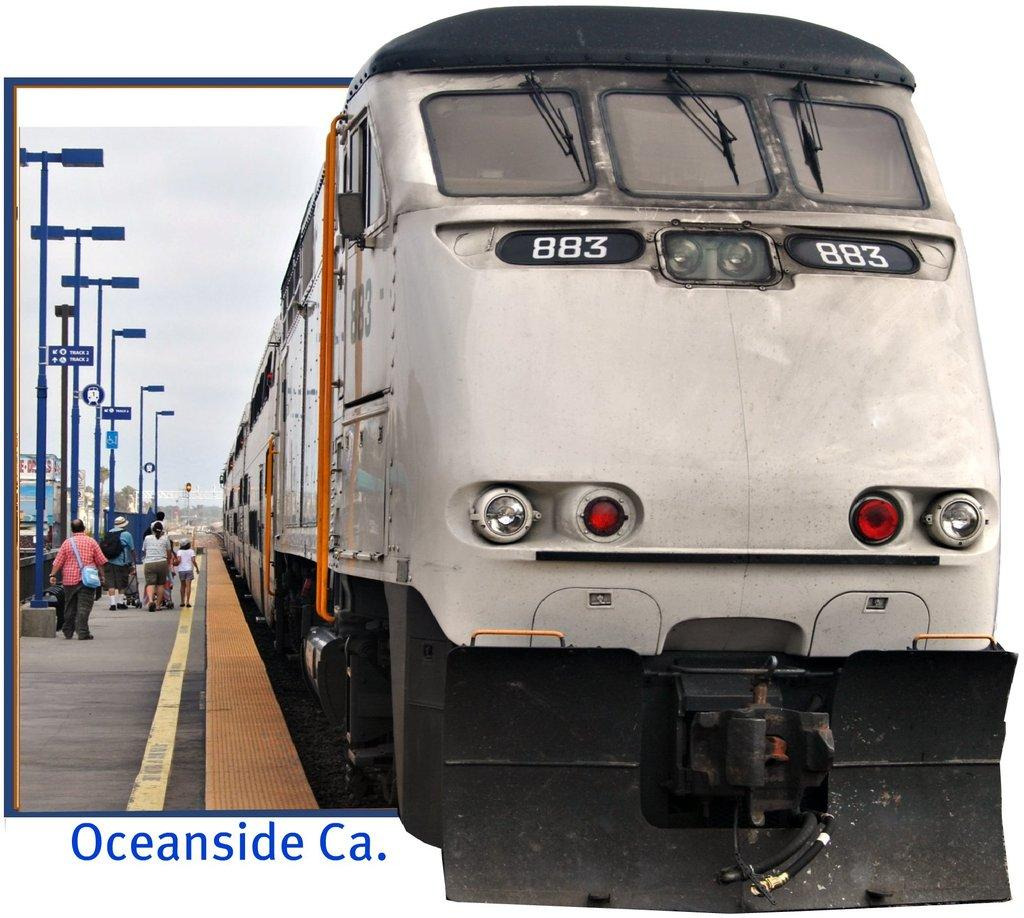Provide a one-sentence caption for the provided image. A train pulls into station in Oceanside California as people prepare to board. 